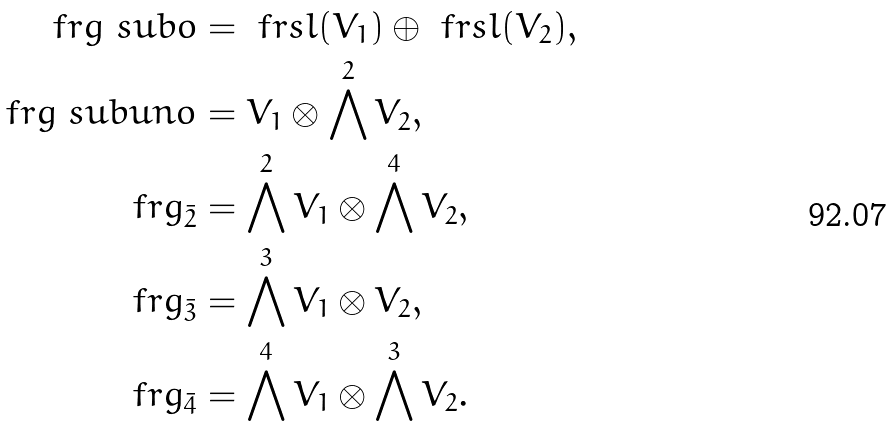Convert formula to latex. <formula><loc_0><loc_0><loc_500><loc_500>\ f r g \ s u b o & = \ f r s l ( V _ { 1 } ) \oplus \ f r s l ( V _ { 2 } ) , \\ \ f r g \ s u b u n o & = V _ { 1 } \otimes \bigwedge ^ { 2 } V _ { 2 } , \\ \ f r g _ { \bar { 2 } } & = \bigwedge ^ { 2 } V _ { 1 } \otimes \bigwedge ^ { 4 } V _ { 2 } , \\ \ f r g _ { \bar { 3 } } & = \bigwedge ^ { 3 } V _ { 1 } \otimes V _ { 2 } , \\ \ f r g _ { \bar { 4 } } & = \bigwedge ^ { 4 } V _ { 1 } \otimes \bigwedge ^ { 3 } V _ { 2 } .</formula> 